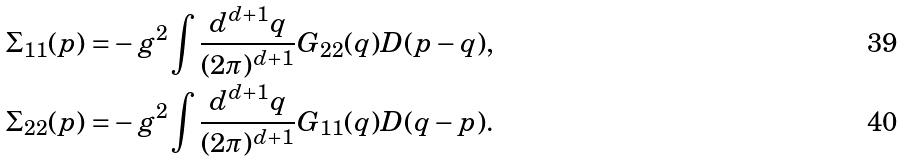Convert formula to latex. <formula><loc_0><loc_0><loc_500><loc_500>\Sigma _ { 1 1 } ( p ) = & - g ^ { 2 } \int \frac { d ^ { d + 1 } q } { ( 2 \pi ) ^ { d + 1 } } G _ { 2 2 } ( q ) D ( p - q ) , \\ \Sigma _ { 2 2 } ( p ) = & - g ^ { 2 } \int \frac { d ^ { d + 1 } q } { ( 2 \pi ) ^ { d + 1 } } G _ { 1 1 } ( q ) D ( q - p ) .</formula> 